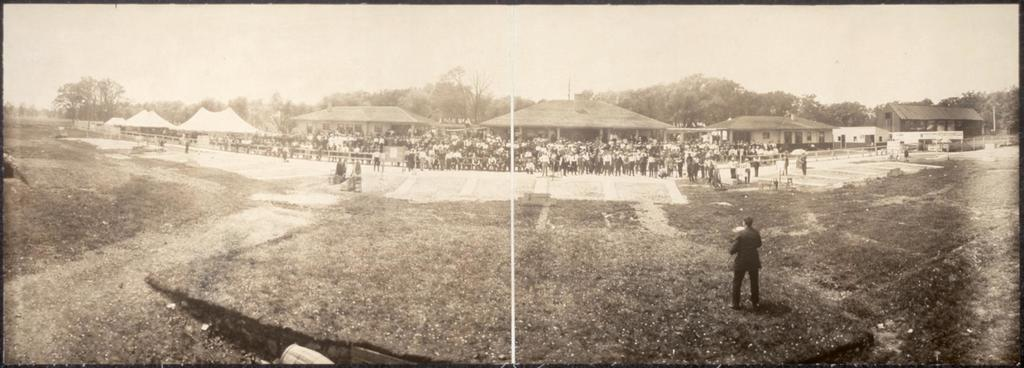What are the people in the image doing? The people in the image are standing on the ground. What can be seen in the background of the image? The background of the image includes trees. What is visible in the sky in the image? The sky is visible in the background of the image. What is the color scheme of the image? The image is black and white in color. What type of zinc is being used to build the truck in the image? There is no truck present in the image, and therefore no zinc can be associated with it. 